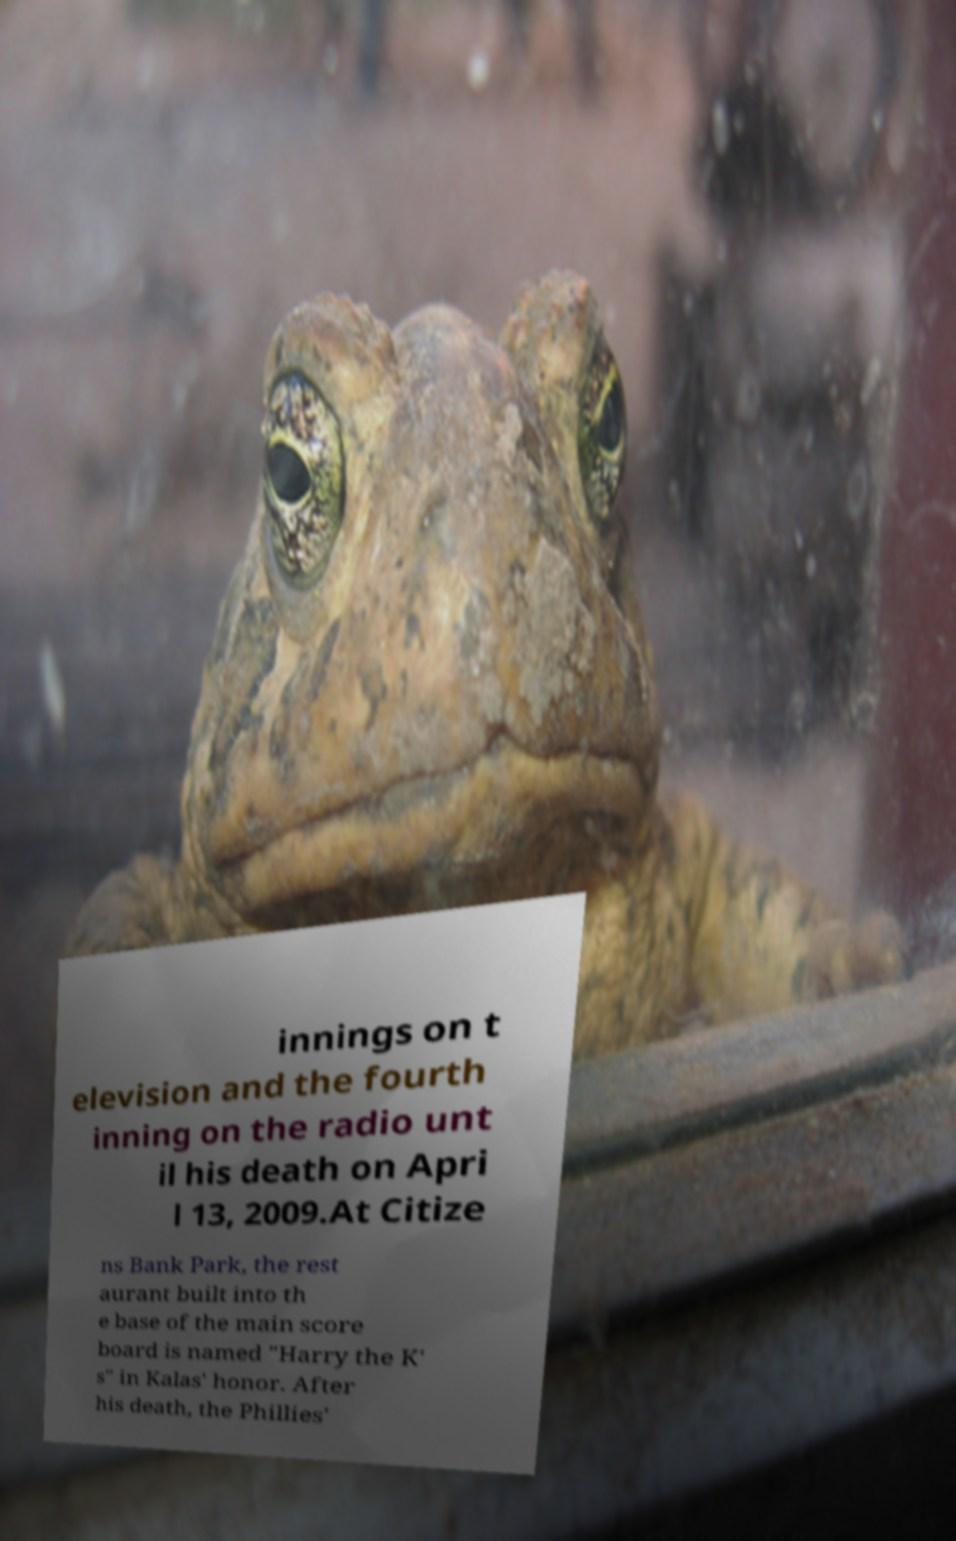Could you extract and type out the text from this image? innings on t elevision and the fourth inning on the radio unt il his death on Apri l 13, 2009.At Citize ns Bank Park, the rest aurant built into th e base of the main score board is named "Harry the K' s" in Kalas' honor. After his death, the Phillies' 